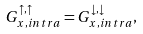Convert formula to latex. <formula><loc_0><loc_0><loc_500><loc_500>G ^ { \uparrow , \uparrow } _ { x , i n t r a } = G ^ { \downarrow , \downarrow } _ { x , i n t r a } ,</formula> 